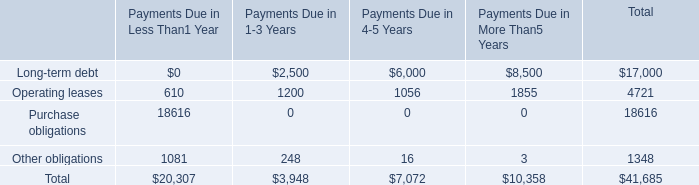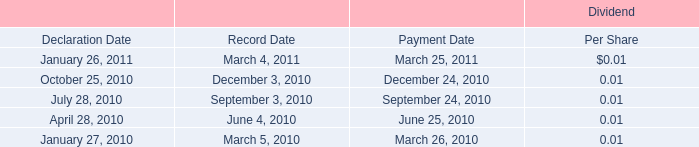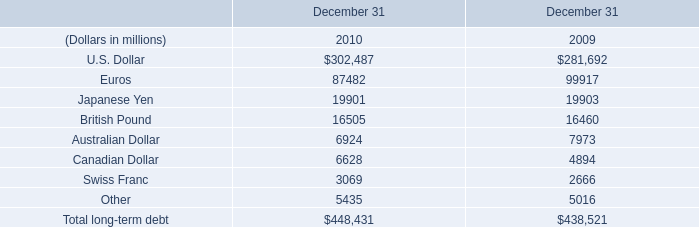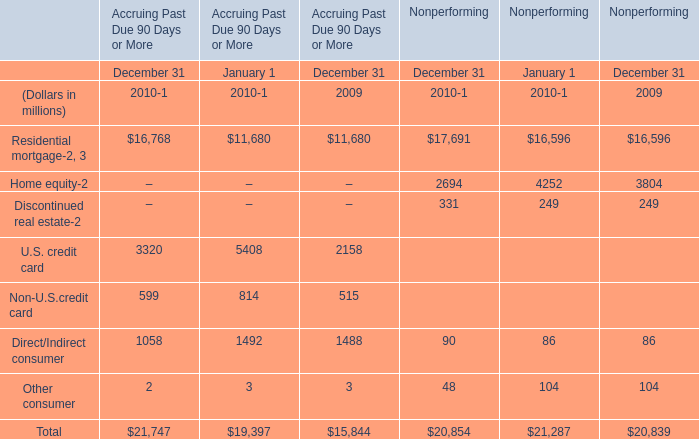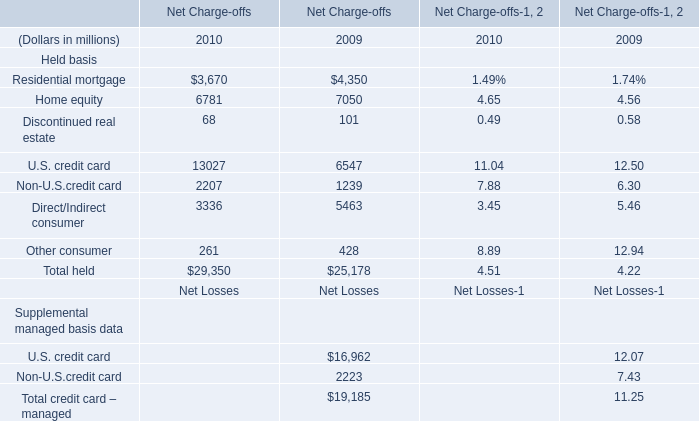In the year with largest amount of Non-U.S.credit card, what's the increasing rate of discontinued real estate？ 
Computations: ((68 - 101) / 101)
Answer: -0.32673. 